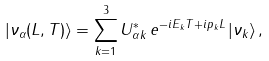Convert formula to latex. <formula><loc_0><loc_0><loc_500><loc_500>| \nu _ { \alpha } ( L , T ) \rangle = \sum _ { k = 1 } ^ { 3 } U _ { \alpha k } ^ { * } \, e ^ { - i E _ { k } T + i p _ { k } L } \, | \nu _ { k } \rangle \, ,</formula> 